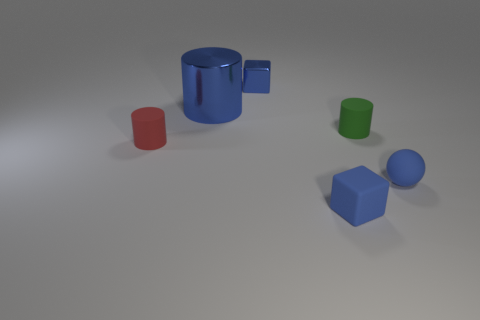Subtract all matte cylinders. How many cylinders are left? 1 Add 4 blue things. How many objects exist? 10 Subtract 3 cylinders. How many cylinders are left? 0 Subtract all red cylinders. How many cylinders are left? 2 Subtract 1 blue balls. How many objects are left? 5 Subtract all spheres. How many objects are left? 5 Subtract all brown cylinders. Subtract all green cubes. How many cylinders are left? 3 Subtract all yellow balls. How many blue cylinders are left? 1 Subtract all big blue shiny things. Subtract all tiny green cylinders. How many objects are left? 4 Add 5 shiny blocks. How many shiny blocks are left? 6 